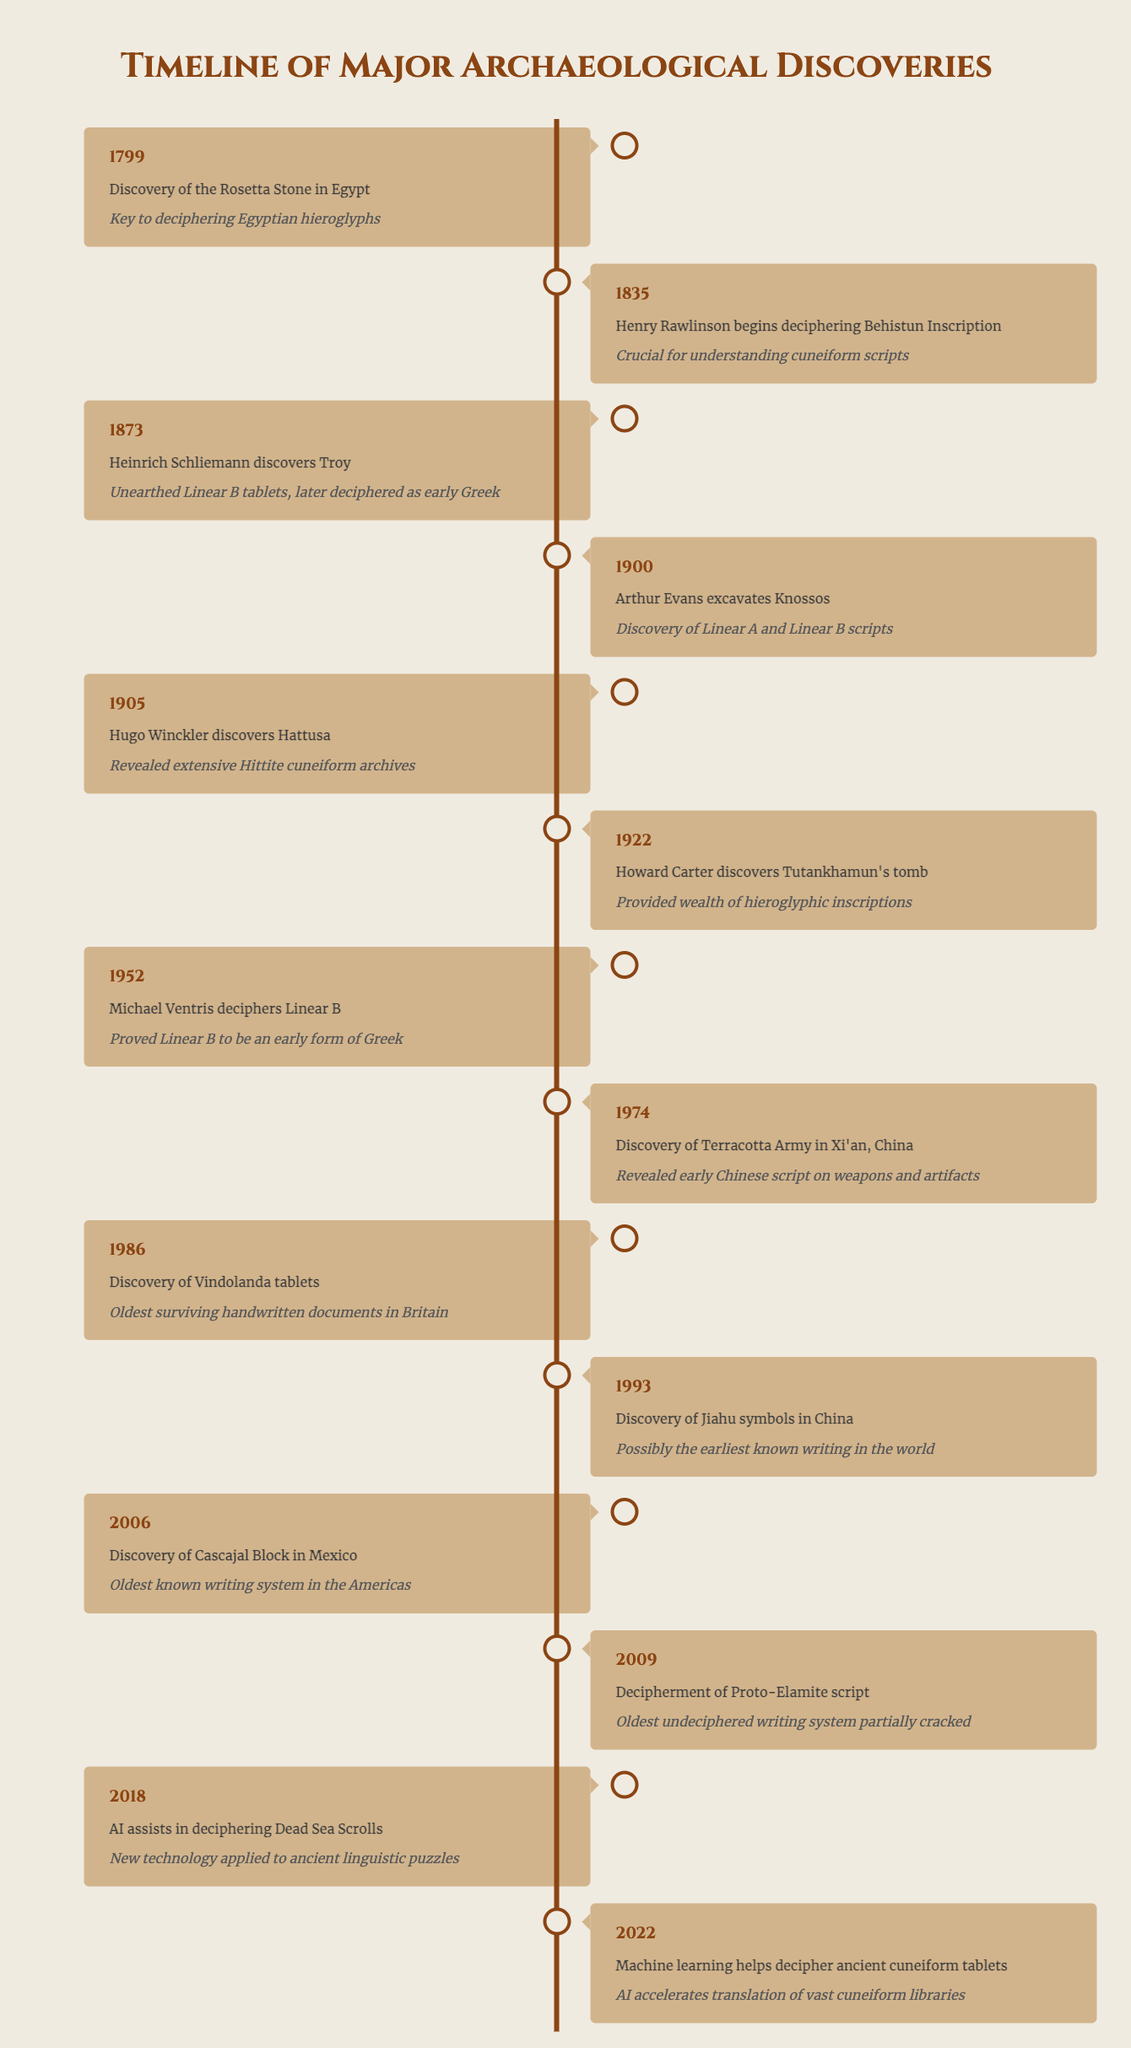What significant discovery was made in 1799? The table shows that in 1799, the "Discovery of the Rosetta Stone in Egypt" was the significant event, which is noted as key to deciphering Egyptian hieroglyphs.
Answer: Discovery of the Rosetta Stone Which event in 1900 is related to Linear scripts? From the table, the event recorded in 1900 is "Arthur Evans excavates Knossos," which involved the discovery of Linear A and Linear B scripts.
Answer: Arthur Evans excavates Knossos Was the discovery of the Terracotta Army made before 2000? The table indicates that the discovery of the Terracotta Army occurred in 1974, which is indeed before the year 2000.
Answer: Yes How many years separated the discovery of the Rosetta Stone and the deciphering of Linear B? The Rosetta Stone was discovered in 1799 and Linear B was deciphered in 1952. The difference in years is 1952 - 1799 = 153 years.
Answer: 153 years Which event had its significance linked to early Greek? The discovery made by Heinrich Schliemann in 1873, "Heinrich Schliemann discovers Troy," is linked to early Greek as it unearthed Linear B tablets that were later deciphered as early Greek.
Answer: Heinrich Schliemann discovers Troy What are the two significant discoveries related to cuneiform scripts in this timeline? According to the table, the two discoveries related to cuneiform scripts are "Henry Rawlinson begins deciphering Behistun Inscription" in 1835 and "Hugo Winckler discovers Hattusa" in 1905, which revealed Hittite cuneiform archives.
Answer: Behistun Inscription and Hattusa Was the discovery of the Vindolanda tablets important for Britain, and if so, how? Yes, the table states that the "Discovery of Vindolanda tablets" in 1986 provided the oldest surviving handwritten documents in Britain, indicating its importance in British history.
Answer: Yes Which discovery occurred last in the list, and what was its significance? The last discovery mentioned in the table is from 2022, "Machine learning helps decipher ancient cuneiform tablets," and its significance is that AI accelerated the translation of vast cuneiform libraries.
Answer: Machine learning helps decipher ancient cuneiform tablets 